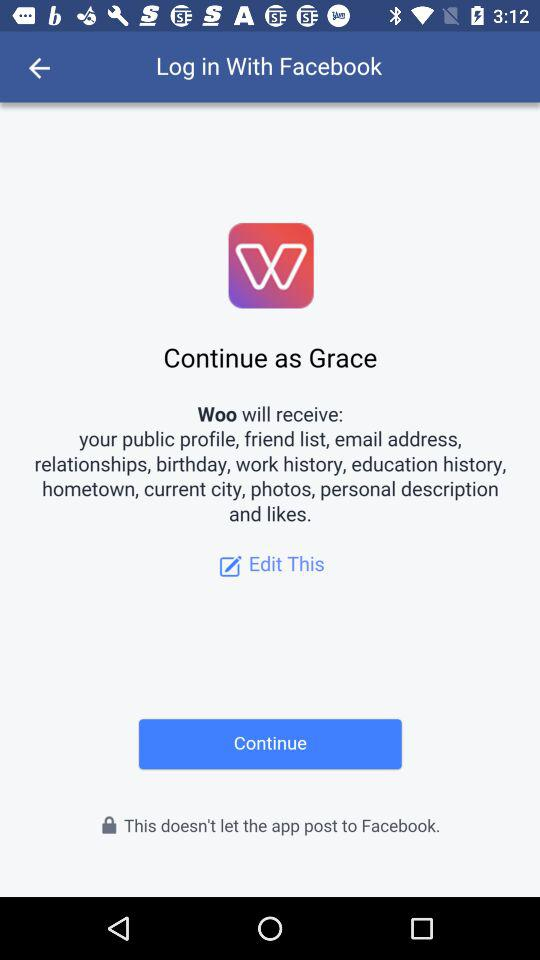What is the user name? The user name is Grace. 